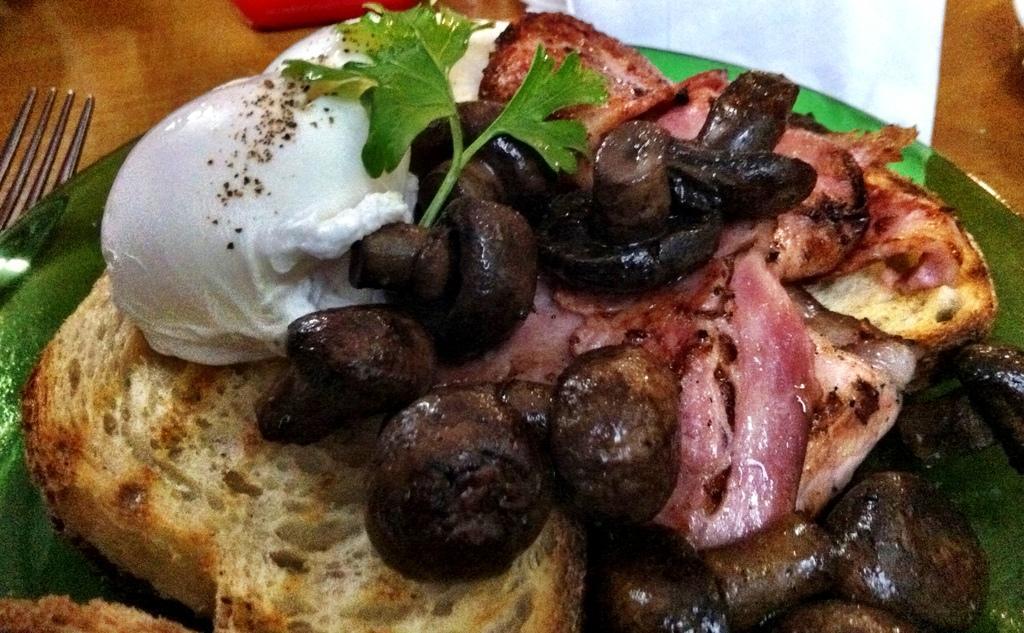Can you describe this image briefly? In this image we can see a plate with some food and two scoops of ice cream, also we can see a fork and some other objects on the table. 